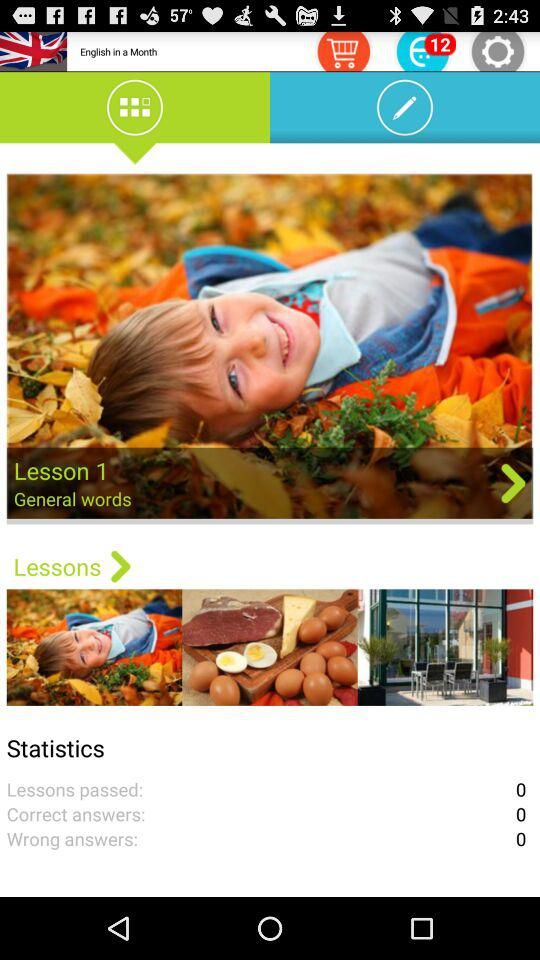What is the lesson number? The lesson number is 1. 